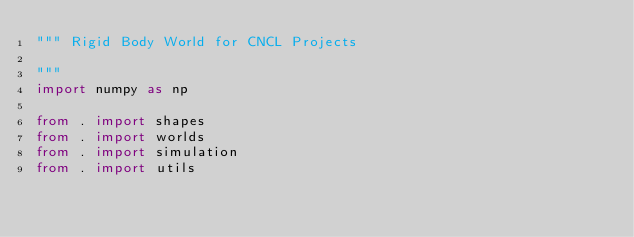Convert code to text. <code><loc_0><loc_0><loc_500><loc_500><_Python_>""" Rigid Body World for CNCL Projects

"""
import numpy as np

from . import shapes
from . import worlds
from . import simulation
from . import utils
</code> 